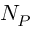<formula> <loc_0><loc_0><loc_500><loc_500>N _ { P }</formula> 